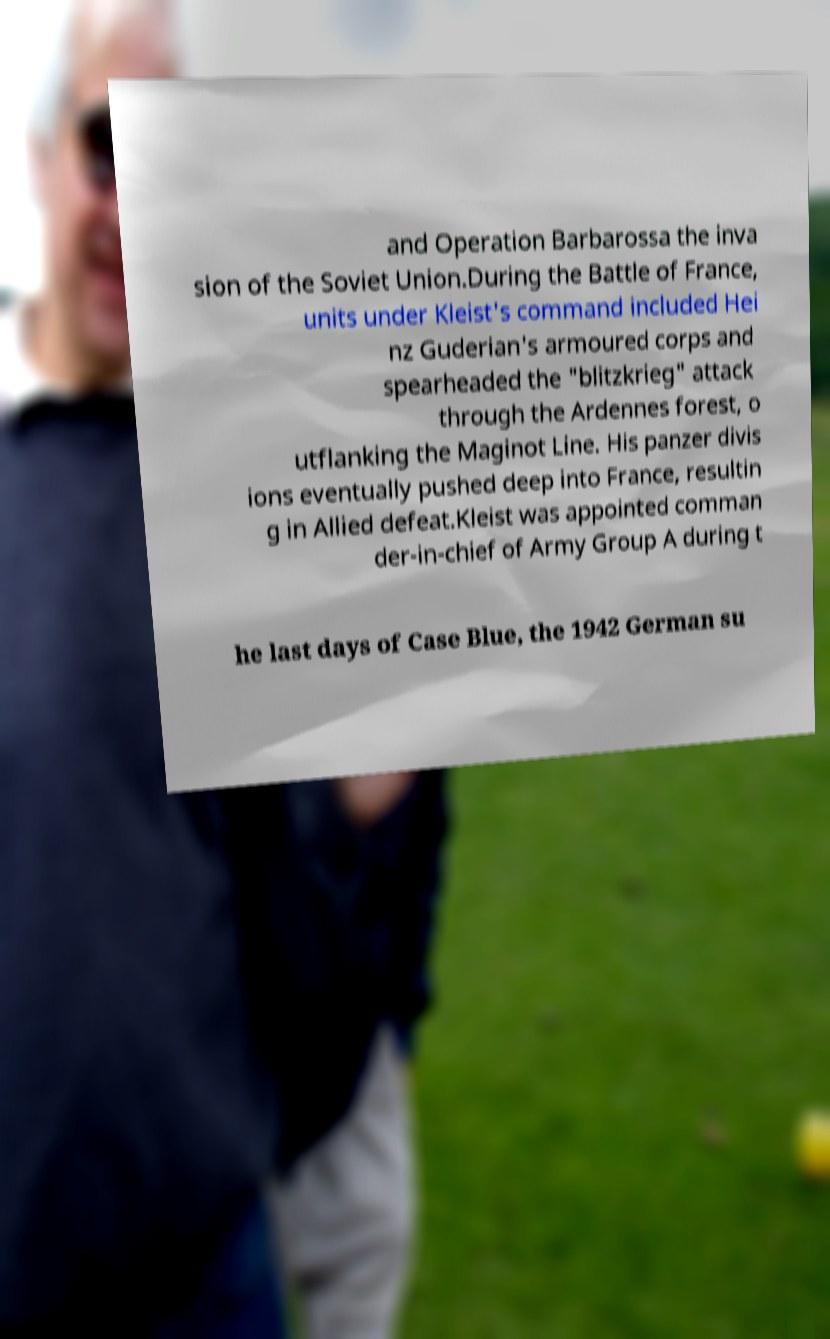Please read and relay the text visible in this image. What does it say? and Operation Barbarossa the inva sion of the Soviet Union.During the Battle of France, units under Kleist's command included Hei nz Guderian's armoured corps and spearheaded the "blitzkrieg" attack through the Ardennes forest, o utflanking the Maginot Line. His panzer divis ions eventually pushed deep into France, resultin g in Allied defeat.Kleist was appointed comman der-in-chief of Army Group A during t he last days of Case Blue, the 1942 German su 